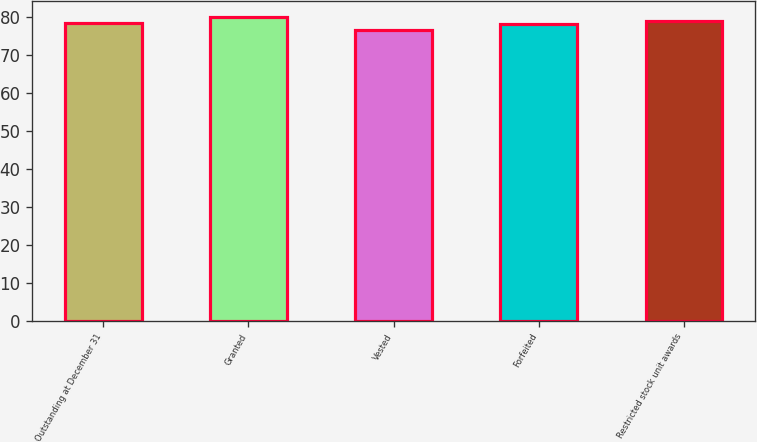Convert chart. <chart><loc_0><loc_0><loc_500><loc_500><bar_chart><fcel>Outstanding at December 31<fcel>Granted<fcel>Vested<fcel>Forfeited<fcel>Restricted stock unit awards<nl><fcel>78.4<fcel>80<fcel>76.4<fcel>78<fcel>78.8<nl></chart> 